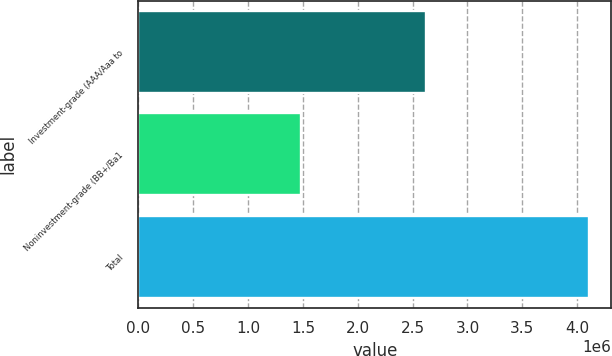Convert chart to OTSL. <chart><loc_0><loc_0><loc_500><loc_500><bar_chart><fcel>Investment-grade (AAA/Aaa to<fcel>Noninvestment-grade (BB+/Ba1<fcel>Total<nl><fcel>2.62444e+06<fcel>1.48281e+06<fcel>4.10725e+06<nl></chart> 